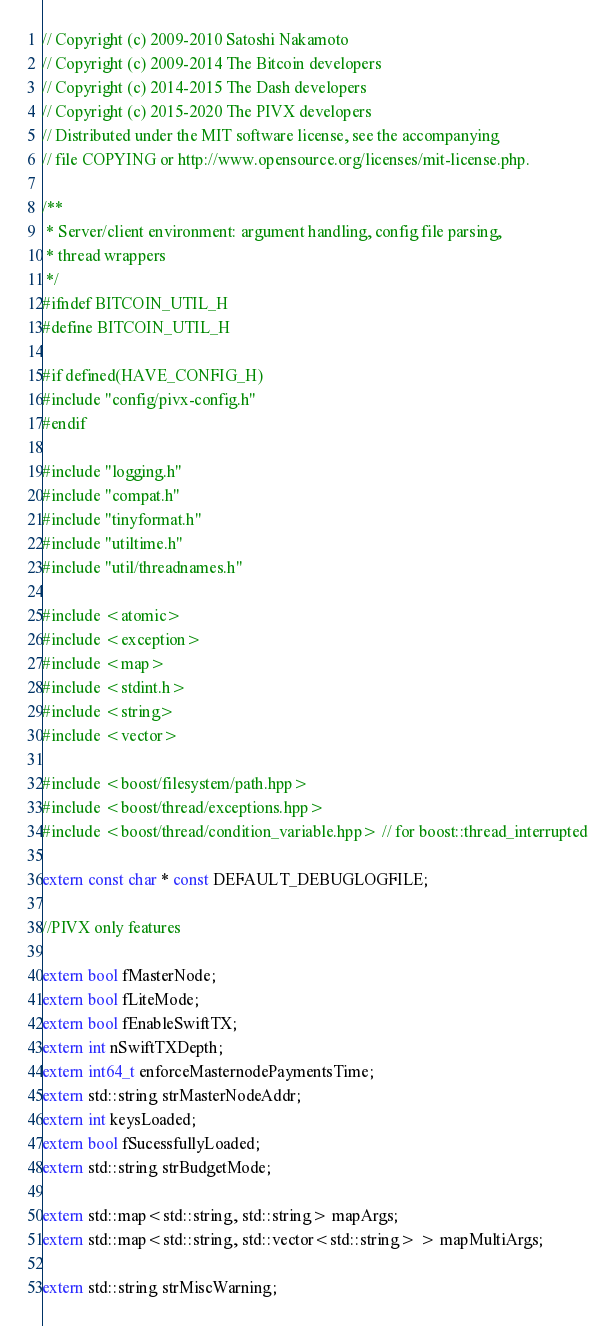Convert code to text. <code><loc_0><loc_0><loc_500><loc_500><_C_>// Copyright (c) 2009-2010 Satoshi Nakamoto
// Copyright (c) 2009-2014 The Bitcoin developers
// Copyright (c) 2014-2015 The Dash developers
// Copyright (c) 2015-2020 The PIVX developers
// Distributed under the MIT software license, see the accompanying
// file COPYING or http://www.opensource.org/licenses/mit-license.php.

/**
 * Server/client environment: argument handling, config file parsing,
 * thread wrappers
 */
#ifndef BITCOIN_UTIL_H
#define BITCOIN_UTIL_H

#if defined(HAVE_CONFIG_H)
#include "config/pivx-config.h"
#endif

#include "logging.h"
#include "compat.h"
#include "tinyformat.h"
#include "utiltime.h"
#include "util/threadnames.h"

#include <atomic>
#include <exception>
#include <map>
#include <stdint.h>
#include <string>
#include <vector>

#include <boost/filesystem/path.hpp>
#include <boost/thread/exceptions.hpp>
#include <boost/thread/condition_variable.hpp> // for boost::thread_interrupted

extern const char * const DEFAULT_DEBUGLOGFILE;

//PIVX only features

extern bool fMasterNode;
extern bool fLiteMode;
extern bool fEnableSwiftTX;
extern int nSwiftTXDepth;
extern int64_t enforceMasternodePaymentsTime;
extern std::string strMasterNodeAddr;
extern int keysLoaded;
extern bool fSucessfullyLoaded;
extern std::string strBudgetMode;

extern std::map<std::string, std::string> mapArgs;
extern std::map<std::string, std::vector<std::string> > mapMultiArgs;

extern std::string strMiscWarning;

</code> 